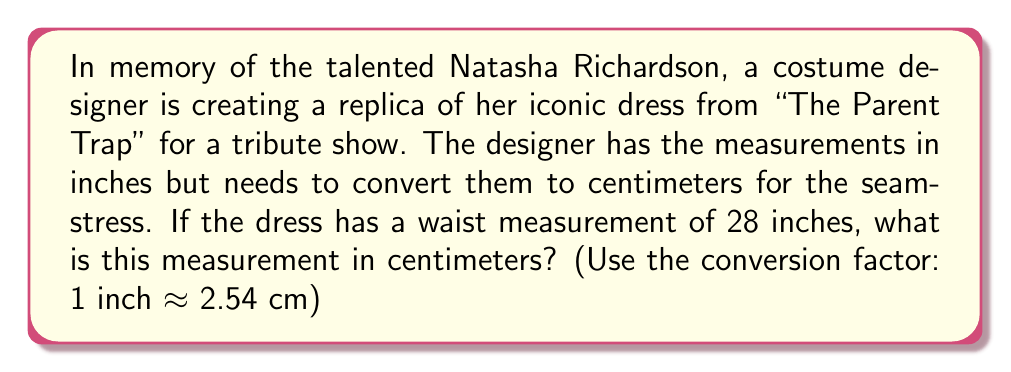Can you answer this question? To convert inches to centimeters, we need to multiply the given measurement by the conversion factor.

Given:
- Waist measurement = 28 inches
- Conversion factor: 1 inch ≈ 2.54 cm

Let's set up the conversion:

$$ 28 \text{ inches} \times \frac{2.54 \text{ cm}}{1 \text{ inch}} $$

Now, let's perform the multiplication:

$$ 28 \times 2.54 = 71.12 \text{ cm} $$

Therefore, the waist measurement of 28 inches is equivalent to 71.12 centimeters.
Answer: 71.12 cm 